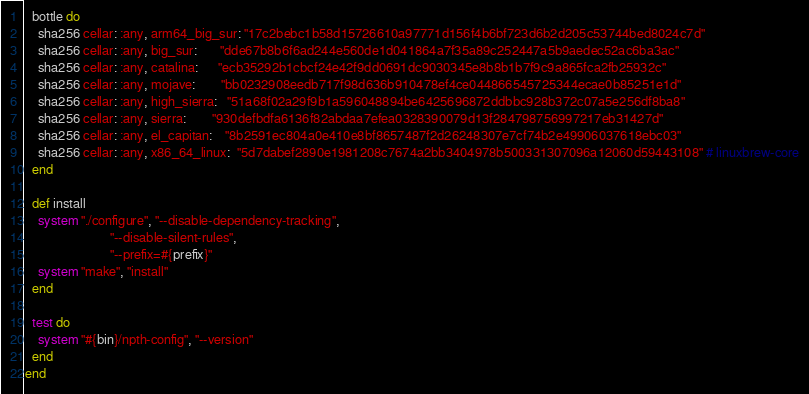<code> <loc_0><loc_0><loc_500><loc_500><_Ruby_>
  bottle do
    sha256 cellar: :any, arm64_big_sur: "17c2bebc1b58d15726610a97771d156f4b6bf723d6b2d205c53744bed8024c7d"
    sha256 cellar: :any, big_sur:       "dde67b8b6f6ad244e560de1d041864a7f35a89c252447a5b9aedec52ac6ba3ac"
    sha256 cellar: :any, catalina:      "ecb35292b1cbcf24e42f9dd0691dc9030345e8b8b1b7f9c9a865fca2fb25932c"
    sha256 cellar: :any, mojave:        "bb0232908eedb717f98d636b910478ef4ce044866545725344ecae0b85251e1d"
    sha256 cellar: :any, high_sierra:   "51a68f02a29f9b1a596048894be6425696872ddbbc928b372c07a5e256df8ba8"
    sha256 cellar: :any, sierra:        "930defbdfa6136f82abdaa7efea0328390079d13f284798756997217eb31427d"
    sha256 cellar: :any, el_capitan:    "8b2591ec804a0e410e8bf8657487f2d26248307e7cf74b2e49906037618ebc03"
    sha256 cellar: :any, x86_64_linux:  "5d7dabef2890e1981208c7674a2bb3404978b500331307096a12060d59443108" # linuxbrew-core
  end

  def install
    system "./configure", "--disable-dependency-tracking",
                          "--disable-silent-rules",
                          "--prefix=#{prefix}"
    system "make", "install"
  end

  test do
    system "#{bin}/npth-config", "--version"
  end
end
</code> 